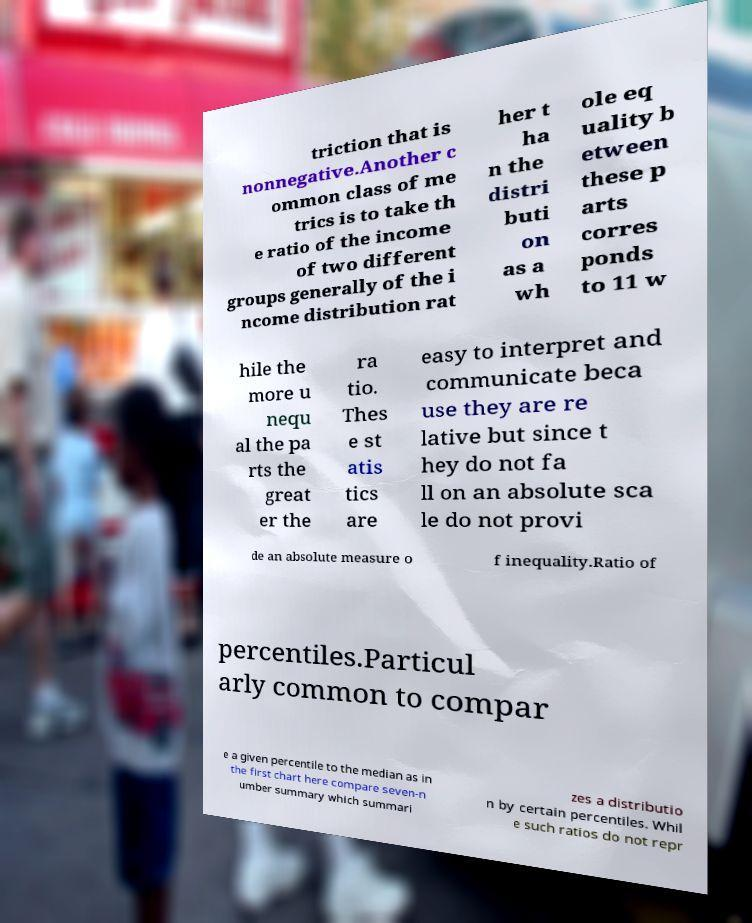Can you read and provide the text displayed in the image?This photo seems to have some interesting text. Can you extract and type it out for me? triction that is nonnegative.Another c ommon class of me trics is to take th e ratio of the income of two different groups generally of the i ncome distribution rat her t ha n the distri buti on as a wh ole eq uality b etween these p arts corres ponds to 11 w hile the more u nequ al the pa rts the great er the ra tio. Thes e st atis tics are easy to interpret and communicate beca use they are re lative but since t hey do not fa ll on an absolute sca le do not provi de an absolute measure o f inequality.Ratio of percentiles.Particul arly common to compar e a given percentile to the median as in the first chart here compare seven-n umber summary which summari zes a distributio n by certain percentiles. Whil e such ratios do not repr 